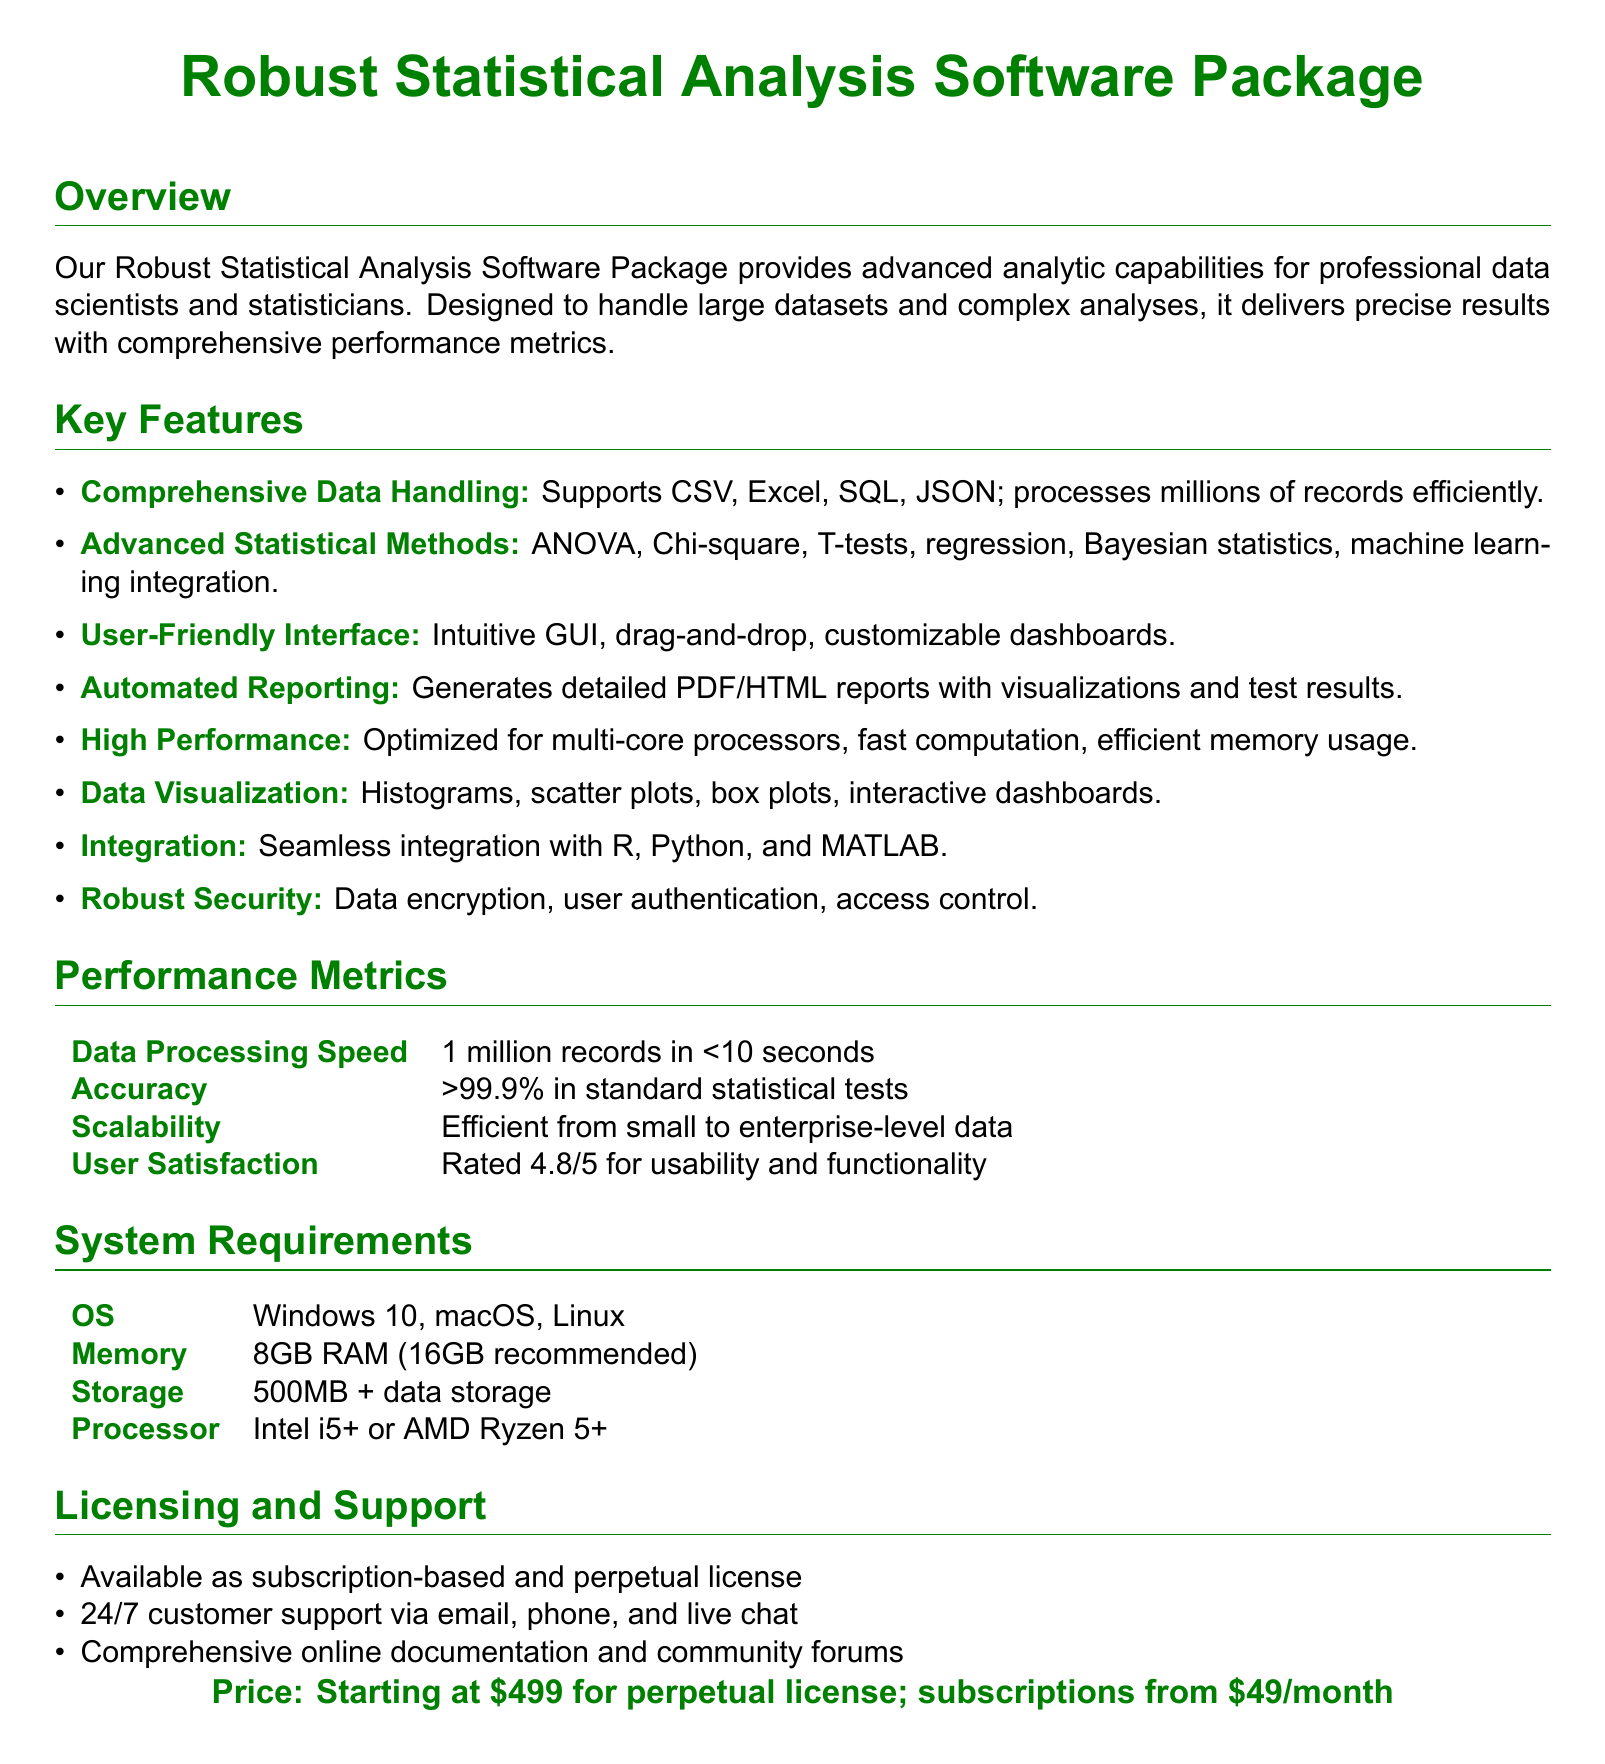What types of data formats are supported? The document lists the supported data formats, which include CSV, Excel, SQL, and JSON.
Answer: CSV, Excel, SQL, JSON What is the user satisfaction rating? The user satisfaction rating is mentioned as a metric in the performance section of the document.
Answer: 4.8/5 What statistical methods are included in the package? The document outlines several statistical methods that are part of the software features.
Answer: ANOVA, Chi-square, T-tests, regression, Bayesian statistics, machine learning integration What is the starting price for a perpetual license? The price information is provided at the end of the document regarding licenses.
Answer: $499 Which operating systems are compatible? The system requirements section specifies the operating systems that can run the software.
Answer: Windows 10, macOS, Linux How quickly can the software process one million records? The document provides a performance metric about data processing speed.
Answer: <10 seconds What is the recommended memory requirement? The system requirements section states the recommended memory for optimal performance.
Answer: 16GB What support options are available? The licensing and support section describes the support options provided with the product.
Answer: 24/7 customer support via email, phone, and live chat How does the software handle data security? The key features outline the security measures integrated into the software.
Answer: Data encryption, user authentication, access control 